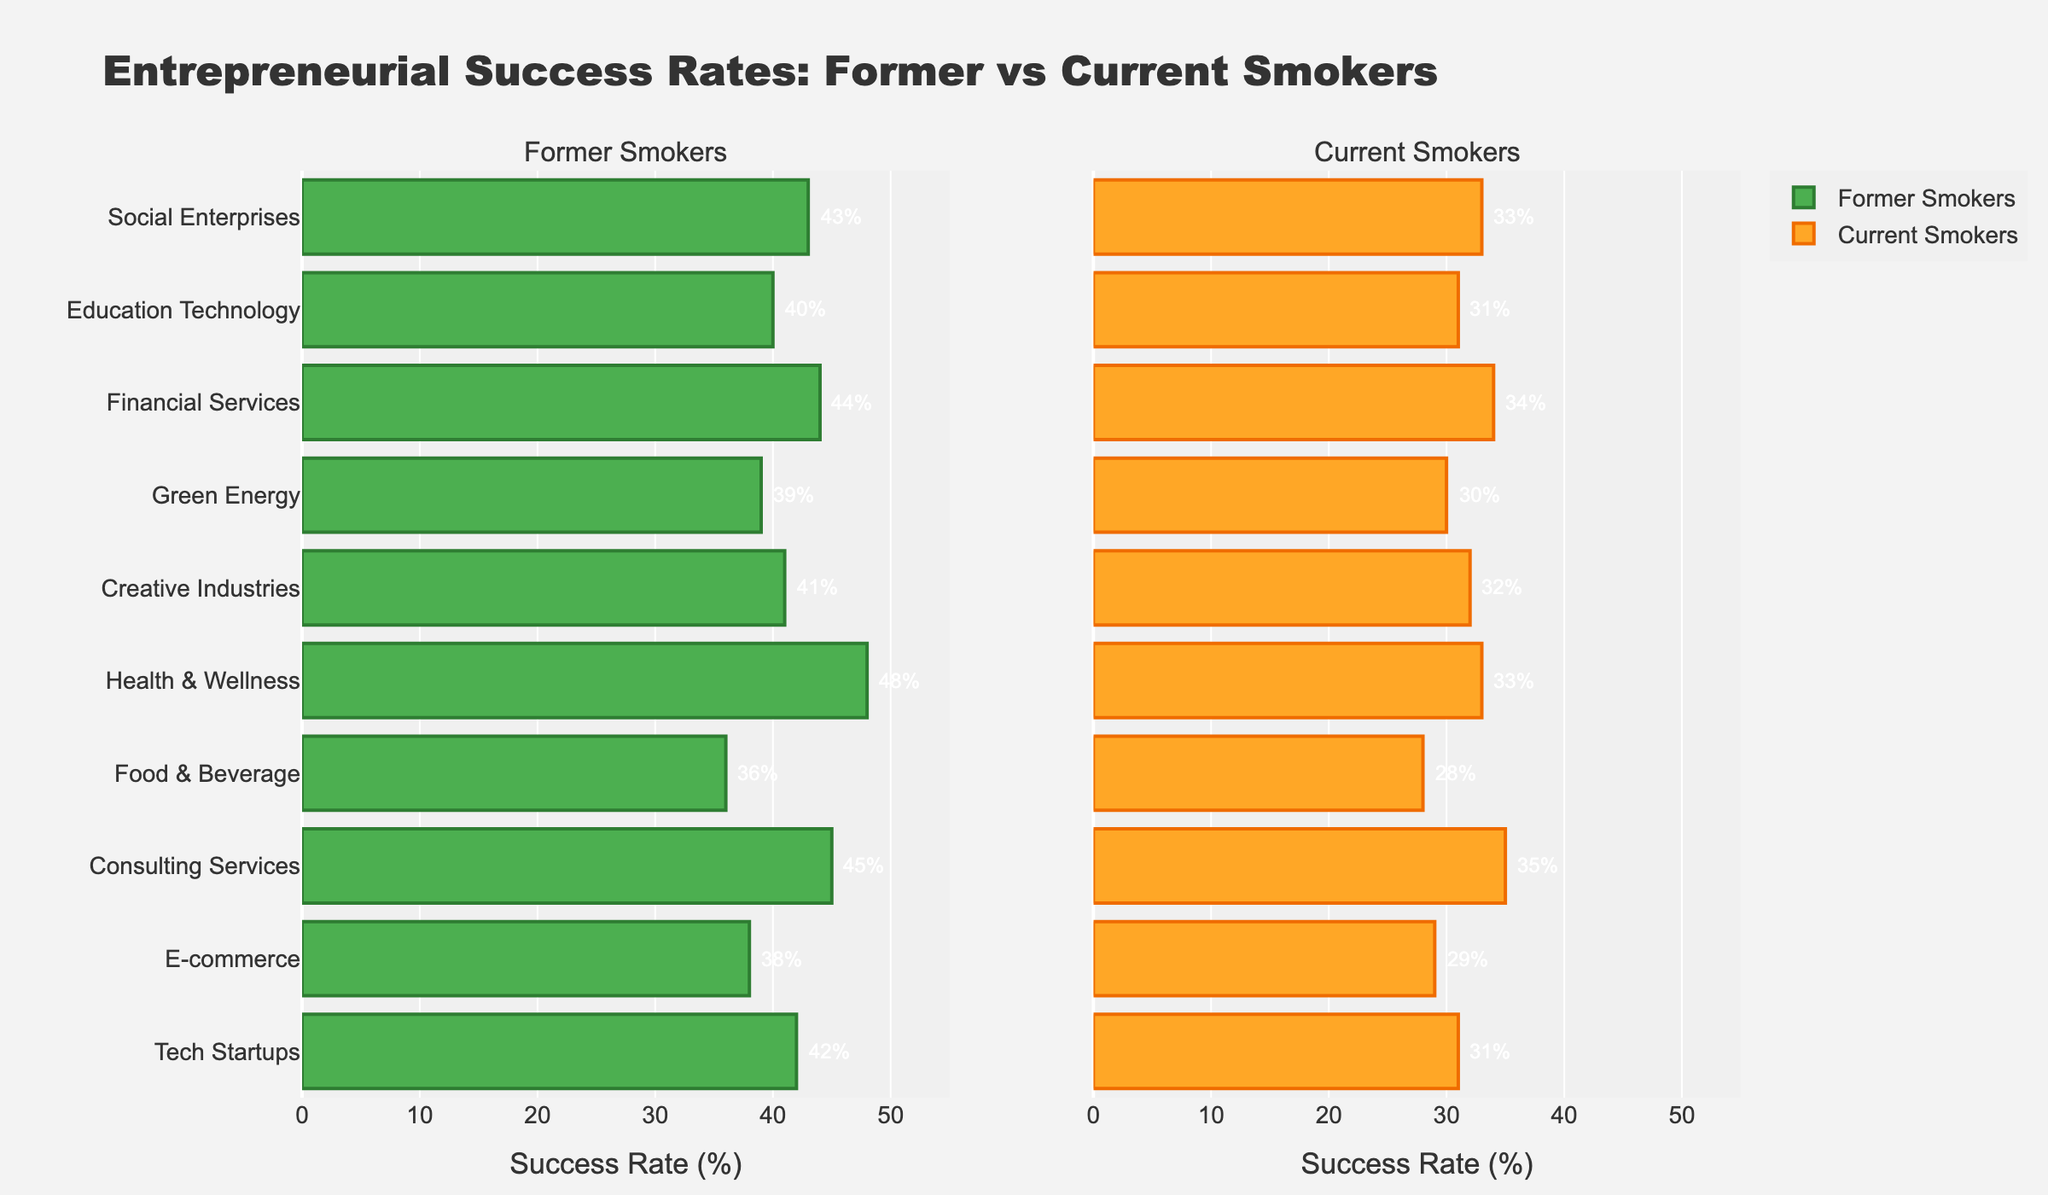How many categories of entrepreneurial types are displayed in the plot? Count the distinct entrepreneurial types listed on the y-axis. There are 10 distinct categories: Tech Startups, E-commerce, Consulting Services, Food & Beverage, Health & Wellness, Creative Industries, Green Energy, Financial Services, Education Technology, and Social Enterprises.
Answer: 10 Which entrepreneurial type has the highest success rate among former smokers? Look for the maximum value on the bar representing former smokers. The highest value is 48% for Health & Wellness.
Answer: Health & Wellness What is the difference in success rates between former and current smokers for Consulting Services? Locate the success rates for Consulting Services in both subplots. Former smokers have a success rate of 45%, and current smokers have 35%. The difference is 45% - 35% = 10%.
Answer: 10% Which group has a higher average success rate across all categories: former smokers or current smokers? Calculate the average success rate for each group. Add the rates for former smokers (42, 38, 45, 36, 48, 41, 39, 44, 40, 43) and current smokers (31, 29, 35, 28, 33, 32, 30, 34, 31, 33), then divide by 10. The averages are (42+38+45+36+48+41+39+44+40+43)/10 = 41.6 for former smokers and (31+29+35+28+33+32+30+34+31+33)/10 = 31.6 for current smokers.
Answer: former smokers Which entrepreneurial type has the smallest gap in success rates between former and current smokers? Calculate the difference for each type: Tech Startups (42-31=11), E-commerce (38-29=9), Consulting Services (45-35=10), Food & Beverage (36-28=8), Health & Wellness (48-33=15), Creative Industries (41-32=9), Green Energy (39-30=9), Financial Services (44-34=10), Education Technology (40-31=9), Social Enterprises (43-33=10). The smallest gap is 8 for Food & Beverage.
Answer: Food & Beverage For which entrepreneurial type do both former and current smokers have success rates above 40%? Identify types where both rates are over 40%. Only Consulting Services (45% former, 35% current) and Financial Services (44% former, 34% current) are relevant. Cross-check values in both subplots.
Answer: None Are the success rates for Green Energy higher for former smokers or current smokers? Compare the success rates for Green Energy in both subplots. Former smokers have 39% and current smokers have 30%. Former smokers have higher rates.
Answer: former smokers What is the success rate for current smokers in E-commerce? Look for the success rate value for E-commerce in the Current Smokers subplot. The rate is 29%.
Answer: 29% Which entrepreneurial type has a success rate of 48% among former smokers? Locate the bar with a success rate of 48% in the Former Smokers subplot. The type is Health & Wellness.
Answer: Health & Wellness 